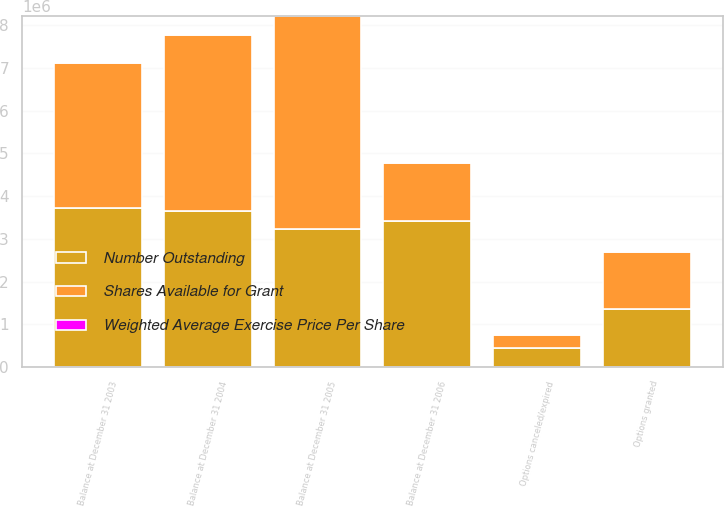Convert chart. <chart><loc_0><loc_0><loc_500><loc_500><stacked_bar_chart><ecel><fcel>Balance at December 31 2003<fcel>Options granted<fcel>Options canceled/expired<fcel>Balance at December 31 2004<fcel>Balance at December 31 2005<fcel>Balance at December 31 2006<nl><fcel>Shares Available for Grant<fcel>3.39989e+06<fcel>1.3508e+06<fcel>296078<fcel>4.12218e+06<fcel>4.98135e+06<fcel>1.3508e+06<nl><fcel>Number Outstanding<fcel>3.72543e+06<fcel>1.3508e+06<fcel>446493<fcel>3.6618e+06<fcel>3.23168e+06<fcel>3.42768e+06<nl><fcel>Weighted Average Exercise Price Per Share<fcel>14.5<fcel>19.14<fcel>21.34<fcel>16.2<fcel>28.93<fcel>50.1<nl></chart> 